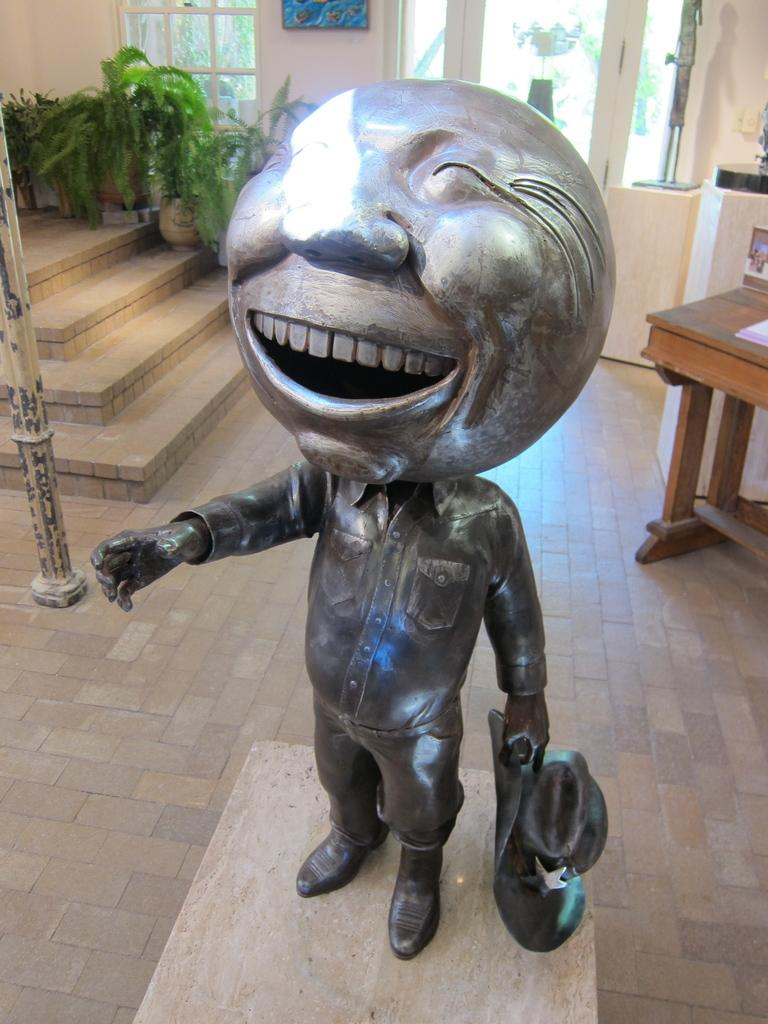What is the main subject of the image? There is a statue in the image. What is the statue depicting? The statue is of a person. What is the person holding in his hand? The person is holding a hat in his hand. How is the person's head shaped? The person's head is in a round shape. What type of zephyr can be seen blowing around the person's head in the image? There is no zephyr present in the image; it is a statue of a person holding a hat. What time of day is depicted in the image? The image does not depict a specific time of day, as it is a statue. 